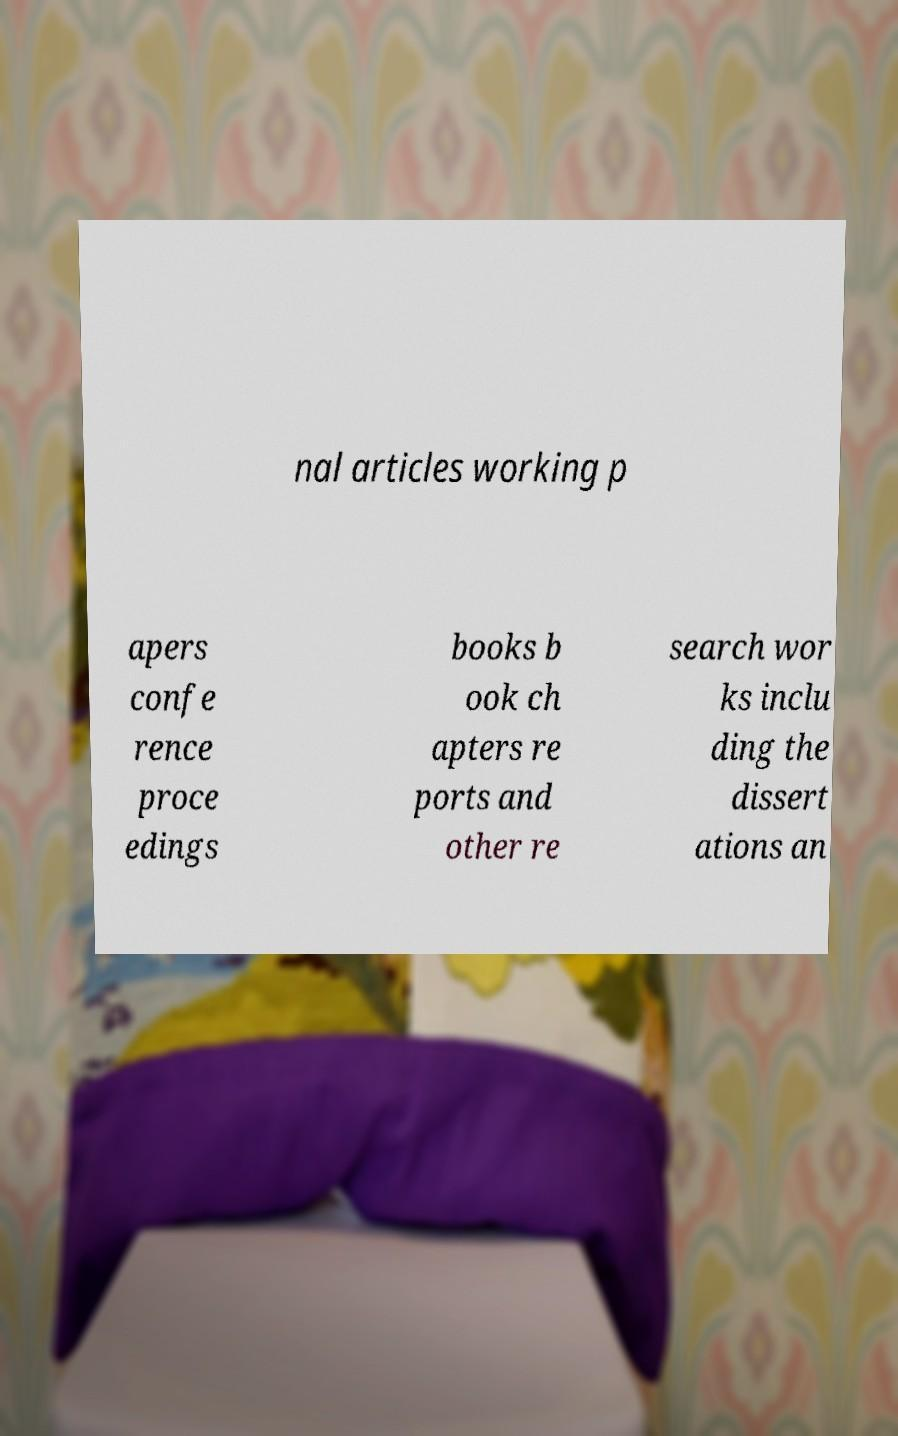What messages or text are displayed in this image? I need them in a readable, typed format. nal articles working p apers confe rence proce edings books b ook ch apters re ports and other re search wor ks inclu ding the dissert ations an 